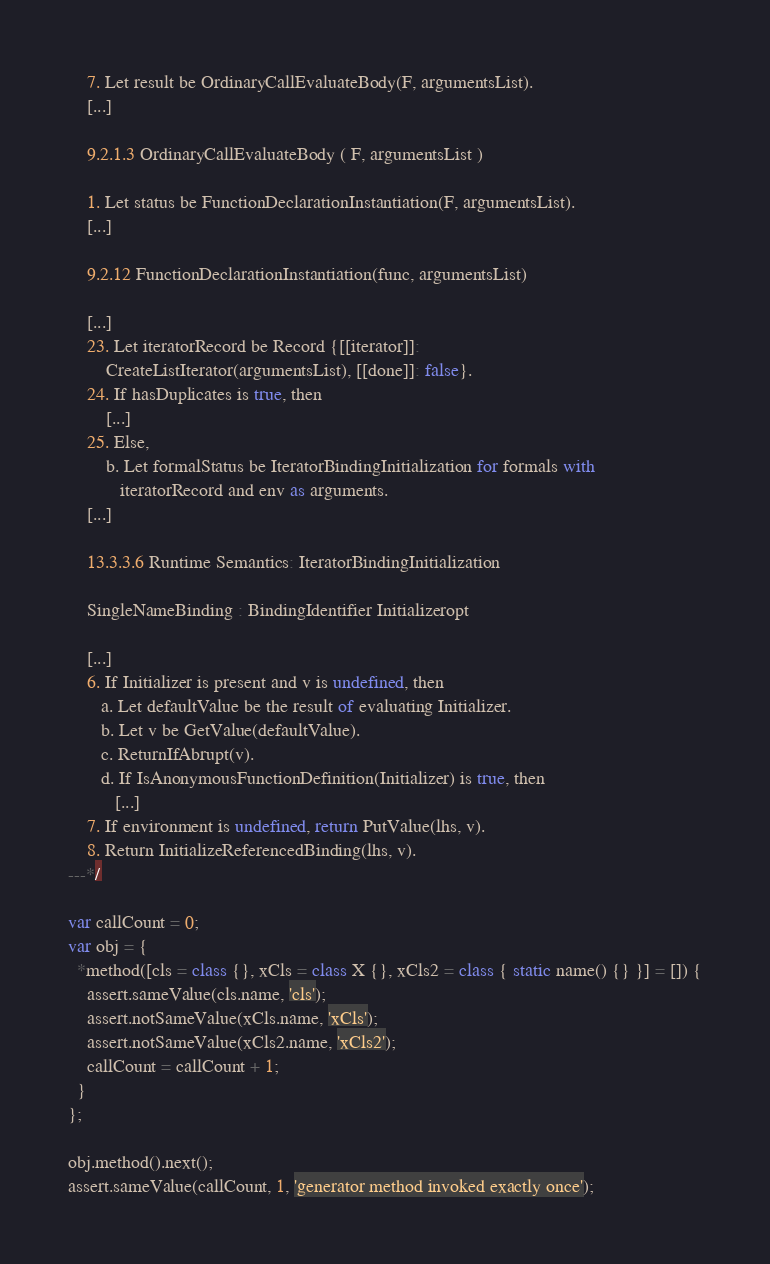Convert code to text. <code><loc_0><loc_0><loc_500><loc_500><_JavaScript_>    7. Let result be OrdinaryCallEvaluateBody(F, argumentsList).
    [...]

    9.2.1.3 OrdinaryCallEvaluateBody ( F, argumentsList )

    1. Let status be FunctionDeclarationInstantiation(F, argumentsList).
    [...]

    9.2.12 FunctionDeclarationInstantiation(func, argumentsList)

    [...]
    23. Let iteratorRecord be Record {[[iterator]]:
        CreateListIterator(argumentsList), [[done]]: false}.
    24. If hasDuplicates is true, then
        [...]
    25. Else,
        b. Let formalStatus be IteratorBindingInitialization for formals with
           iteratorRecord and env as arguments.
    [...]

    13.3.3.6 Runtime Semantics: IteratorBindingInitialization

    SingleNameBinding : BindingIdentifier Initializeropt

    [...]
    6. If Initializer is present and v is undefined, then
       a. Let defaultValue be the result of evaluating Initializer.
       b. Let v be GetValue(defaultValue).
       c. ReturnIfAbrupt(v).
       d. If IsAnonymousFunctionDefinition(Initializer) is true, then
          [...]
    7. If environment is undefined, return PutValue(lhs, v).
    8. Return InitializeReferencedBinding(lhs, v).
---*/

var callCount = 0;
var obj = {
  *method([cls = class {}, xCls = class X {}, xCls2 = class { static name() {} }] = []) {
    assert.sameValue(cls.name, 'cls');
    assert.notSameValue(xCls.name, 'xCls');
    assert.notSameValue(xCls2.name, 'xCls2');
    callCount = callCount + 1;
  }
};

obj.method().next();
assert.sameValue(callCount, 1, 'generator method invoked exactly once');
</code> 